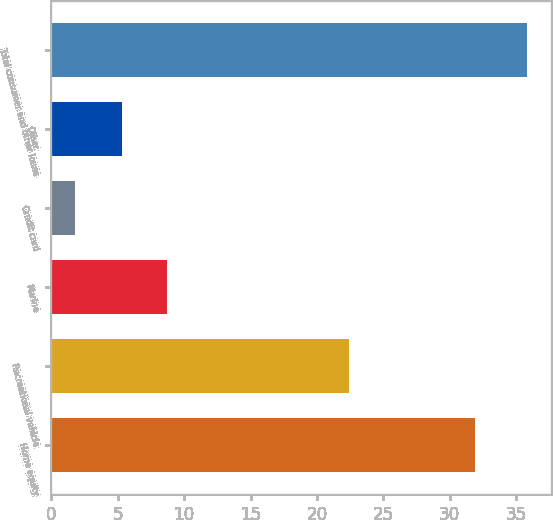Convert chart. <chart><loc_0><loc_0><loc_500><loc_500><bar_chart><fcel>Home equity<fcel>Recreational vehicle<fcel>Marine<fcel>Credit card<fcel>Other<fcel>Total consumer and other loans<nl><fcel>31.9<fcel>22.4<fcel>8.7<fcel>1.8<fcel>5.3<fcel>35.8<nl></chart> 